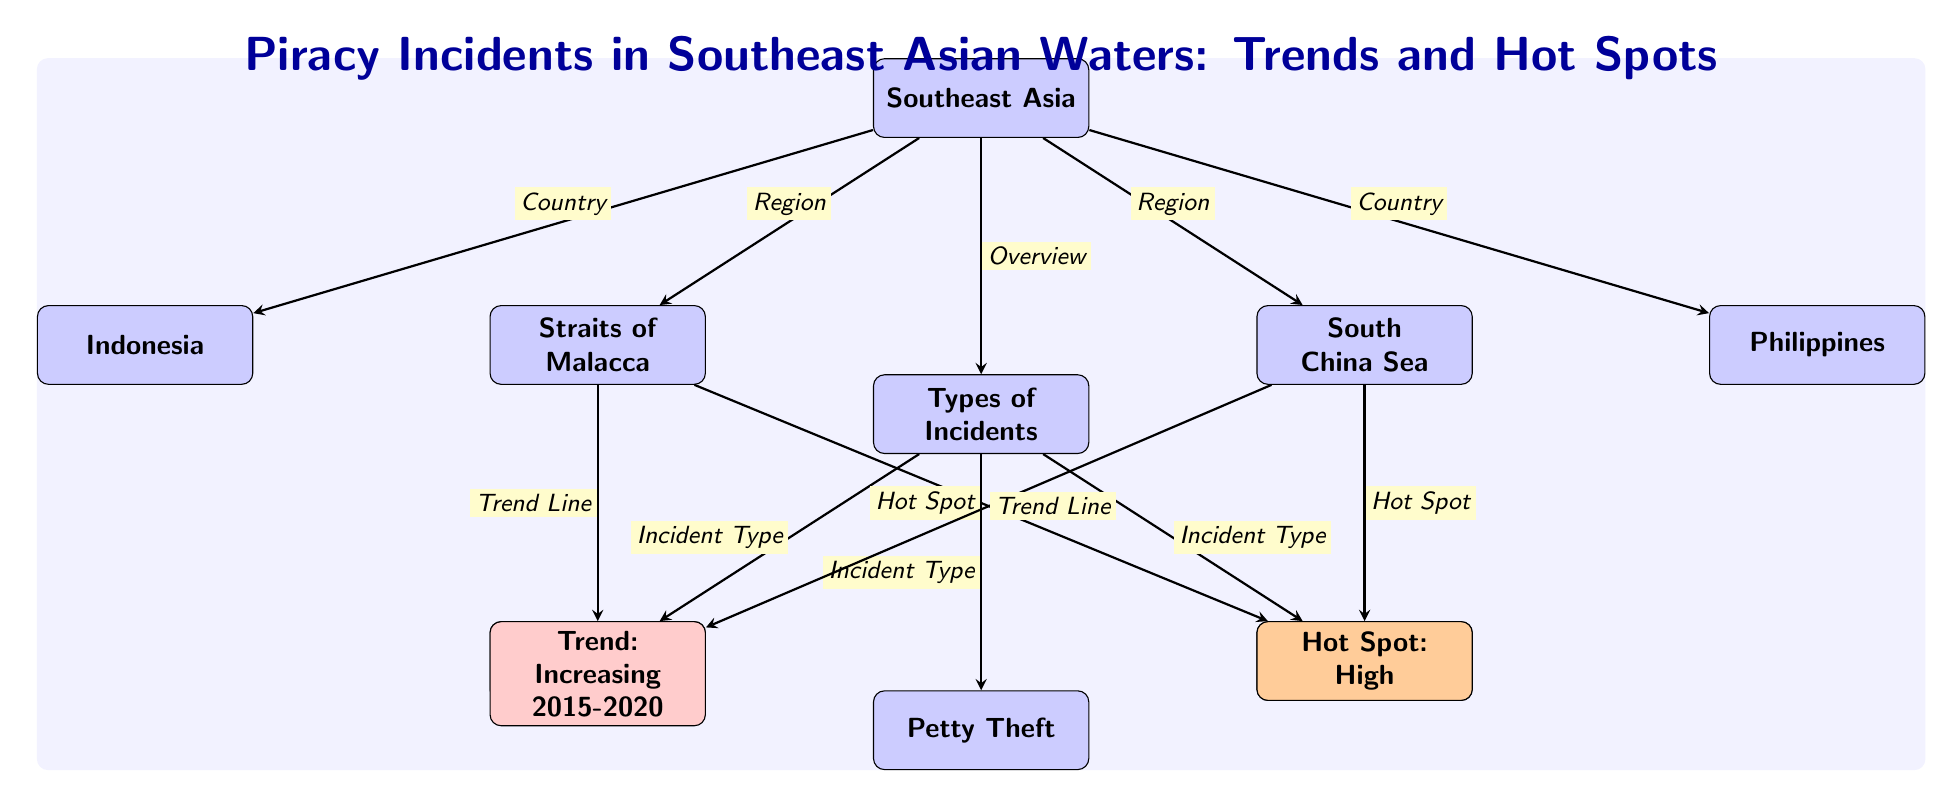What is the main title of the diagram? The title, located at the top of the diagram, states "Piracy Incidents in Southeast Asian Waters: Trends and Hot Spots."
Answer: Piracy Incidents in Southeast Asian Waters: Trends and Hot Spots How many incident types are shown in the diagram? There are three types of incidents listed under "Types of Incidents": Armed Robbery, Petty Theft, and Hijacking. Counting these gives us a total of three.
Answer: 3 What region is indicated as a "Hot Spot"? Under the South China Sea node, the diagram highlights "Hot Spot: High," indicating that this area has a high level of piracy incidents.
Answer: South China Sea Which maritime area has a trend labeled as "Increasing 2015-2020"? The trend "Increasing 2015-2020" is associated with both the Straits of Malacca and the South China Sea, indicating a rise in incidents in these regions during that time period.
Answer: Straits of Malacca and South China Sea What type of piracy incident is linked to the Armed Robbery node? The Armed Robbery node, connected to "Types of Incidents," highlights one specific type of piracy incident characterized by threats to life or property.
Answer: Armed Robbery Which two countries are specifically mentioned in the diagram? The diagram includes Indonesia and the Philippines, which are listed under the Southeast Asia region, indicating their relevance to piracy incidents.
Answer: Indonesia and Philippines Which incident type is positioned directly below "Types of Incidents"? The diagram shows "Armed Robbery" as the first incident type directly below the "Types of Incidents" node, indicating its significance among the listed types.
Answer: Armed Robbery How does the "Straits of Malacca" connect to other elements in the diagram? The Straits of Malacca node connects to two key elements: it has a trend line indicating an increase in incidents, and it is highlighted as a hot spot for piracy activity, linking both a temporal aspect and geographical relevance.
Answer: Increasing trend and Hot Spot What color fill is used for the "Trend: Increasing 2015-2020" node? The "Trend: Increasing 2015-2020" node is filled with red, symbolizing a warning or alert regarding rising piracy incidents.
Answer: Red Which node indicates an overview of piracy incidents? The "Types of Incidents" serves as the overview node, summarizing the various forms of piracy activity observed in Southeast Asian waters.
Answer: Types of Incidents 